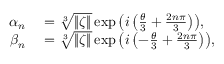<formula> <loc_0><loc_0><loc_500><loc_500>\begin{array} { r l } { \alpha _ { n } } & = \sqrt { [ } 3 ] { \| \zeta \| } \exp { \left ( i \left ( \frac { \theta } { 3 } + \frac { 2 n \pi } { 3 } \right ) \right ) } , } \\ { \beta _ { n } } & = \sqrt { [ } 3 ] { \| \zeta \| } \exp { \left ( i \left ( - \frac { \theta } { 3 } + \frac { 2 n \pi } { 3 } \right ) \right ) } , } \end{array}</formula> 